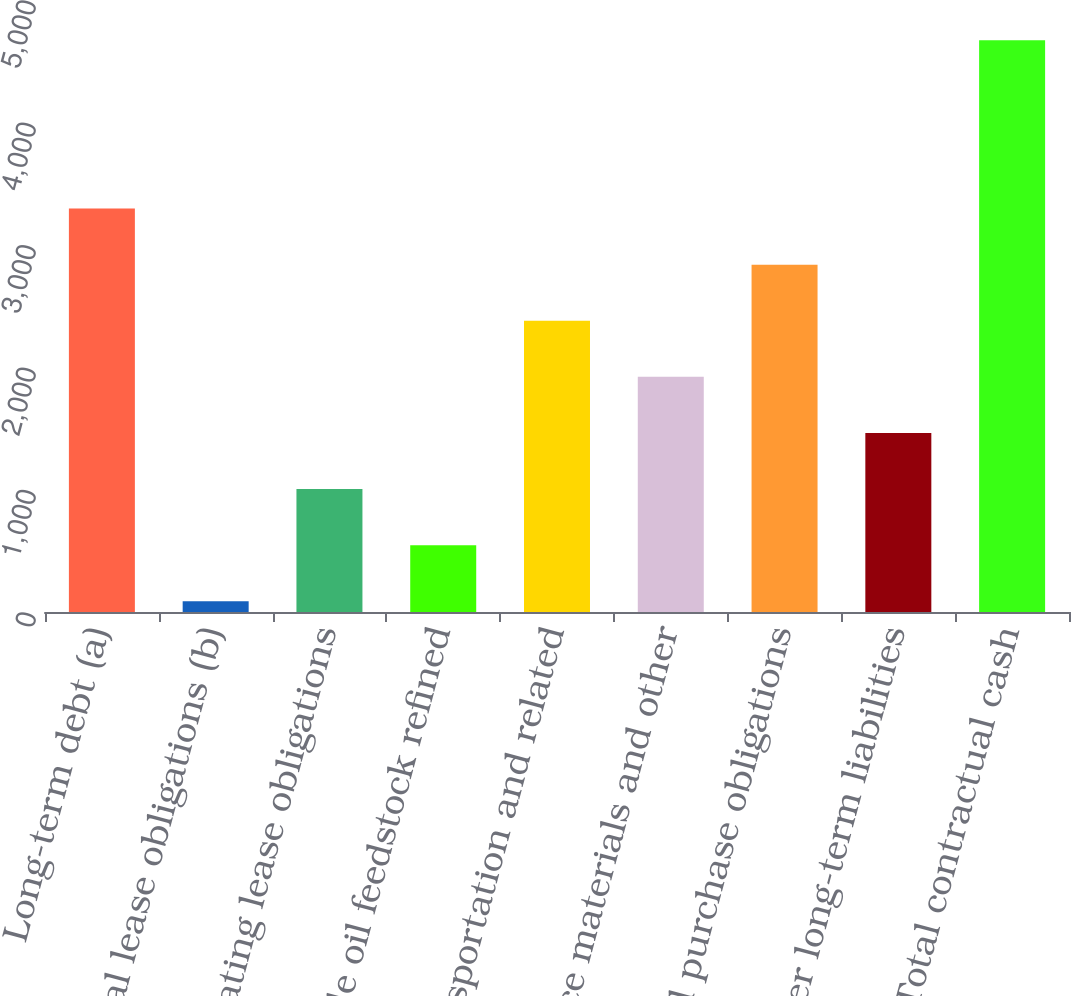Convert chart. <chart><loc_0><loc_0><loc_500><loc_500><bar_chart><fcel>Long-term debt (a)<fcel>Capital lease obligations (b)<fcel>Operating lease obligations<fcel>Crude oil feedstock refined<fcel>Transportation and related<fcel>Service materials and other<fcel>Total purchase obligations<fcel>Other long-term liabilities<fcel>Total contractual cash<nl><fcel>3296.1<fcel>88<fcel>1004.6<fcel>546.3<fcel>2379.5<fcel>1921.2<fcel>2837.8<fcel>1462.9<fcel>4671<nl></chart> 